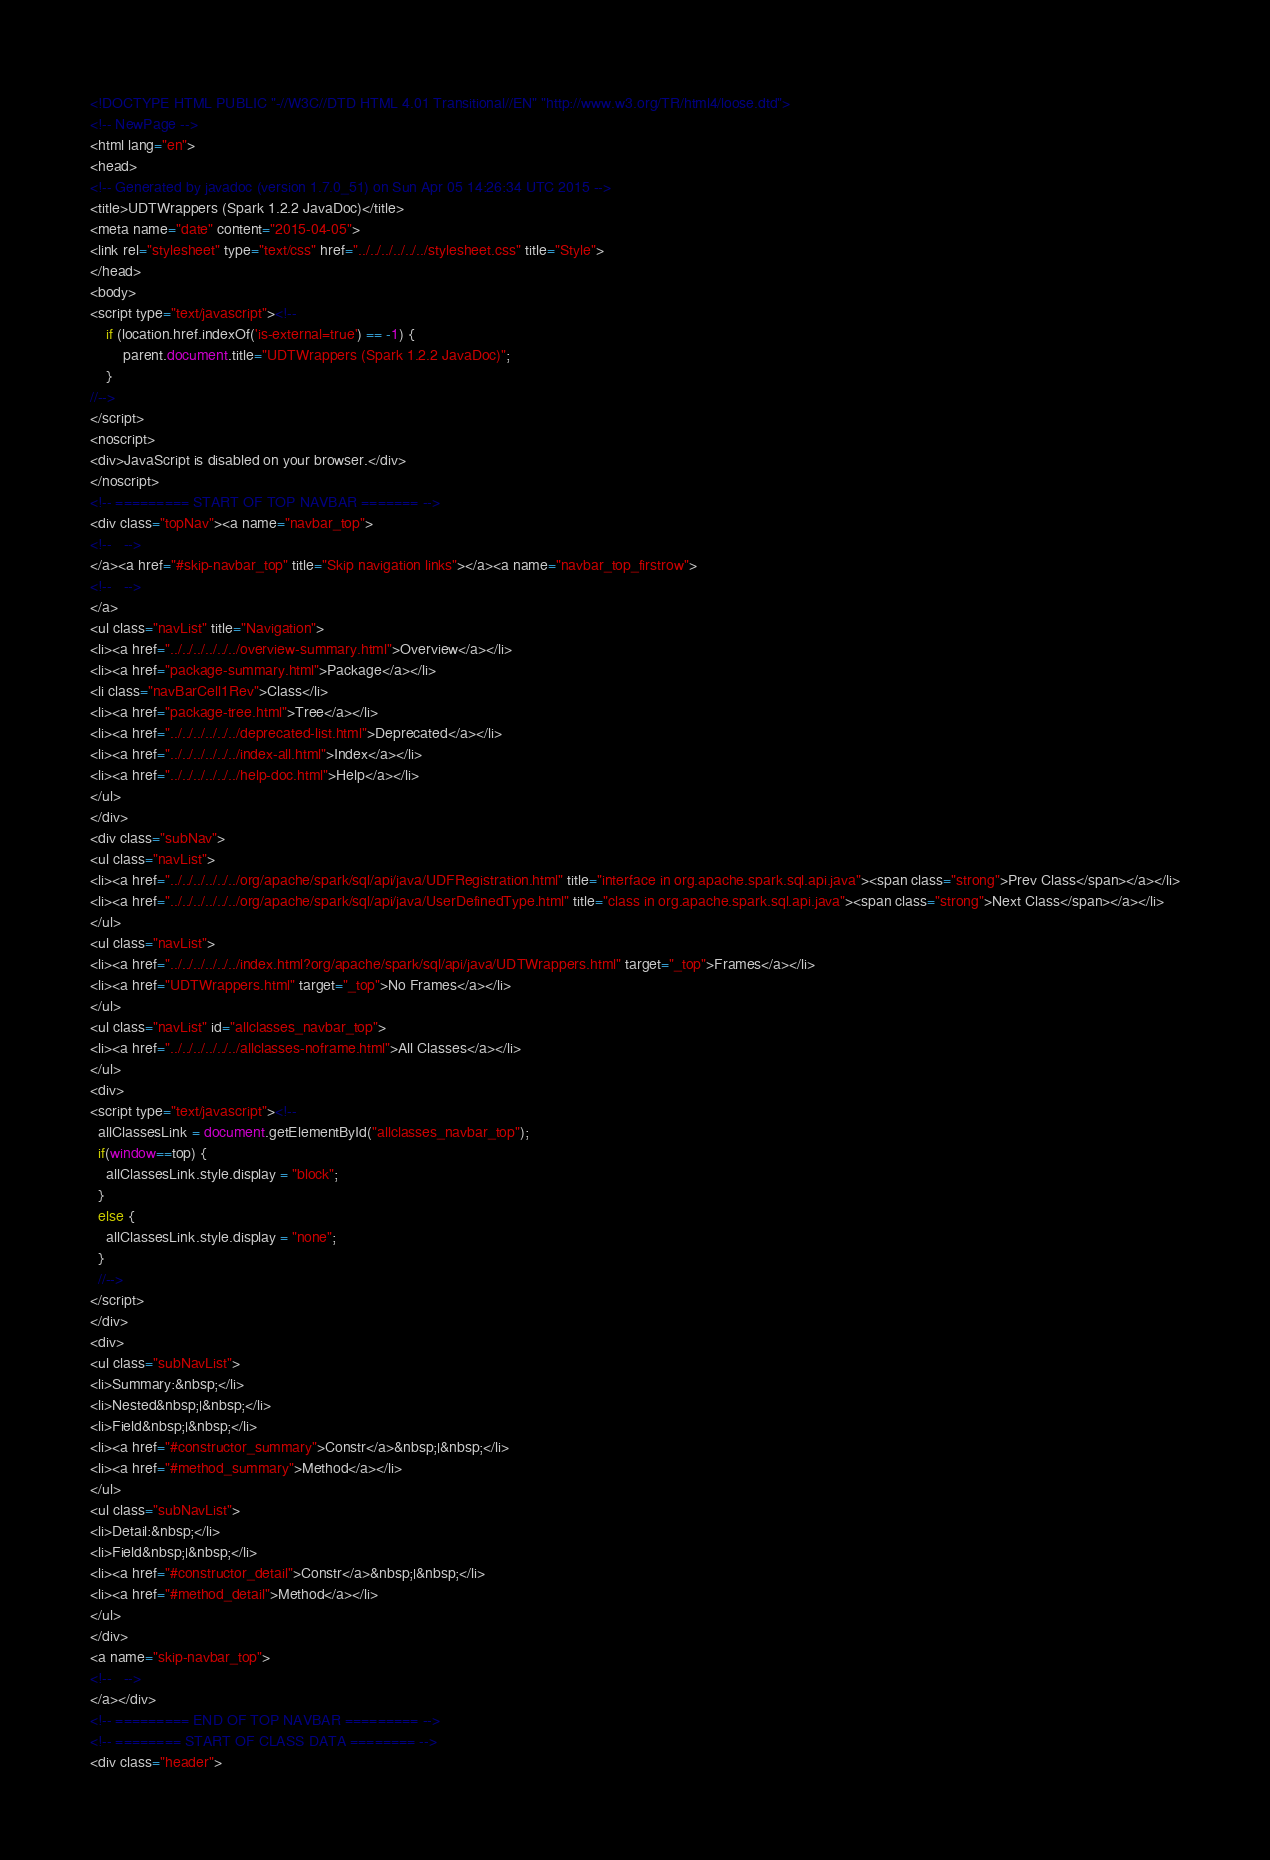<code> <loc_0><loc_0><loc_500><loc_500><_HTML_><!DOCTYPE HTML PUBLIC "-//W3C//DTD HTML 4.01 Transitional//EN" "http://www.w3.org/TR/html4/loose.dtd">
<!-- NewPage -->
<html lang="en">
<head>
<!-- Generated by javadoc (version 1.7.0_51) on Sun Apr 05 14:26:34 UTC 2015 -->
<title>UDTWrappers (Spark 1.2.2 JavaDoc)</title>
<meta name="date" content="2015-04-05">
<link rel="stylesheet" type="text/css" href="../../../../../../stylesheet.css" title="Style">
</head>
<body>
<script type="text/javascript"><!--
    if (location.href.indexOf('is-external=true') == -1) {
        parent.document.title="UDTWrappers (Spark 1.2.2 JavaDoc)";
    }
//-->
</script>
<noscript>
<div>JavaScript is disabled on your browser.</div>
</noscript>
<!-- ========= START OF TOP NAVBAR ======= -->
<div class="topNav"><a name="navbar_top">
<!--   -->
</a><a href="#skip-navbar_top" title="Skip navigation links"></a><a name="navbar_top_firstrow">
<!--   -->
</a>
<ul class="navList" title="Navigation">
<li><a href="../../../../../../overview-summary.html">Overview</a></li>
<li><a href="package-summary.html">Package</a></li>
<li class="navBarCell1Rev">Class</li>
<li><a href="package-tree.html">Tree</a></li>
<li><a href="../../../../../../deprecated-list.html">Deprecated</a></li>
<li><a href="../../../../../../index-all.html">Index</a></li>
<li><a href="../../../../../../help-doc.html">Help</a></li>
</ul>
</div>
<div class="subNav">
<ul class="navList">
<li><a href="../../../../../../org/apache/spark/sql/api/java/UDFRegistration.html" title="interface in org.apache.spark.sql.api.java"><span class="strong">Prev Class</span></a></li>
<li><a href="../../../../../../org/apache/spark/sql/api/java/UserDefinedType.html" title="class in org.apache.spark.sql.api.java"><span class="strong">Next Class</span></a></li>
</ul>
<ul class="navList">
<li><a href="../../../../../../index.html?org/apache/spark/sql/api/java/UDTWrappers.html" target="_top">Frames</a></li>
<li><a href="UDTWrappers.html" target="_top">No Frames</a></li>
</ul>
<ul class="navList" id="allclasses_navbar_top">
<li><a href="../../../../../../allclasses-noframe.html">All Classes</a></li>
</ul>
<div>
<script type="text/javascript"><!--
  allClassesLink = document.getElementById("allclasses_navbar_top");
  if(window==top) {
    allClassesLink.style.display = "block";
  }
  else {
    allClassesLink.style.display = "none";
  }
  //-->
</script>
</div>
<div>
<ul class="subNavList">
<li>Summary:&nbsp;</li>
<li>Nested&nbsp;|&nbsp;</li>
<li>Field&nbsp;|&nbsp;</li>
<li><a href="#constructor_summary">Constr</a>&nbsp;|&nbsp;</li>
<li><a href="#method_summary">Method</a></li>
</ul>
<ul class="subNavList">
<li>Detail:&nbsp;</li>
<li>Field&nbsp;|&nbsp;</li>
<li><a href="#constructor_detail">Constr</a>&nbsp;|&nbsp;</li>
<li><a href="#method_detail">Method</a></li>
</ul>
</div>
<a name="skip-navbar_top">
<!--   -->
</a></div>
<!-- ========= END OF TOP NAVBAR ========= -->
<!-- ======== START OF CLASS DATA ======== -->
<div class="header"></code> 